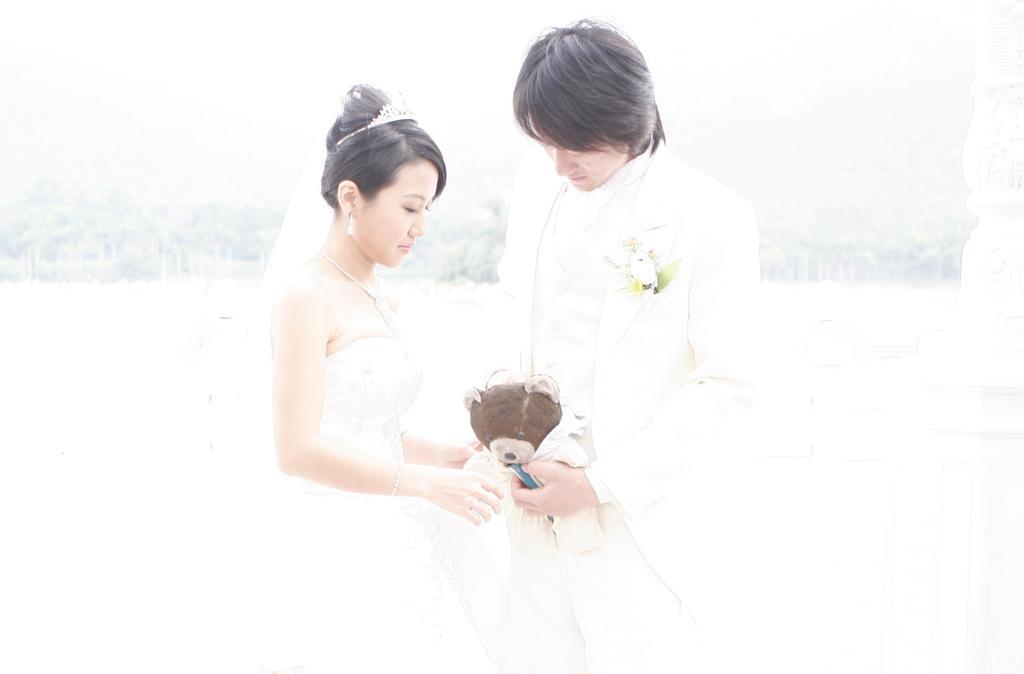Can you describe this image briefly? This image is taken outdoors. This image is an edited image. In the background there are many trees. On the right side of the image there is a pillar. In the middle of the image a man and a woman are standing and a man is holding a teddy bear in his hands. 